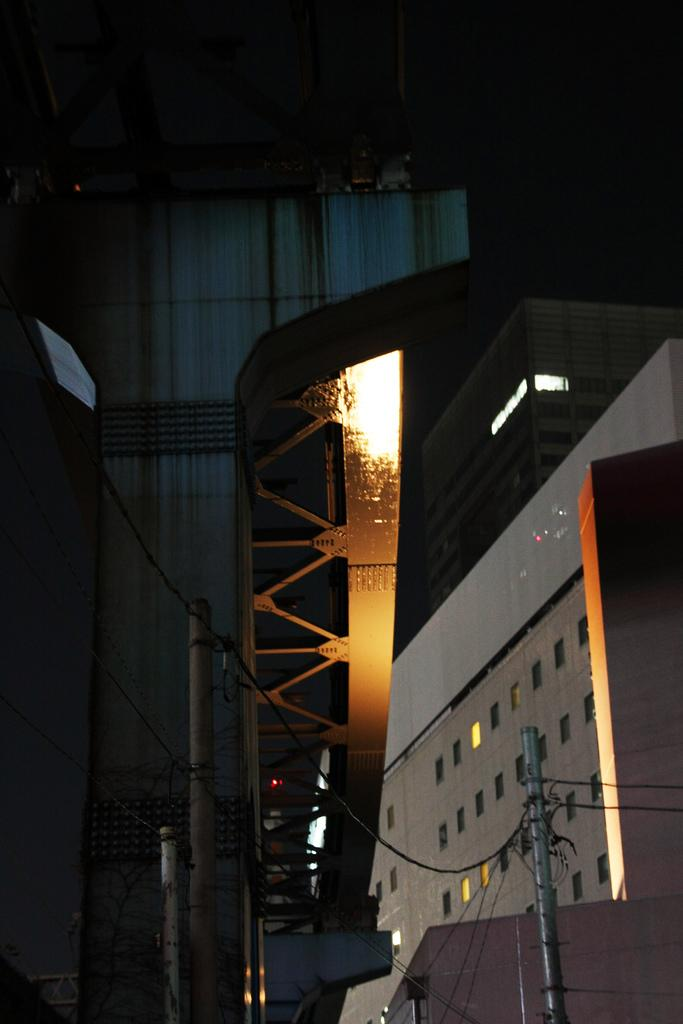What is the main object in the image? There is a silver color pole in the image. What is connected to the pole? Cables are connected to the pole. What can be seen in the background of the image? There are buildings and poles in the background of the image. How would you describe the background of the image? The background of the image is dark in color. What type of ring can be seen on the ship in the image? There is no ship or ring present in the image; it features a silver color pole with cables connected to it, and the background includes buildings and poles. 